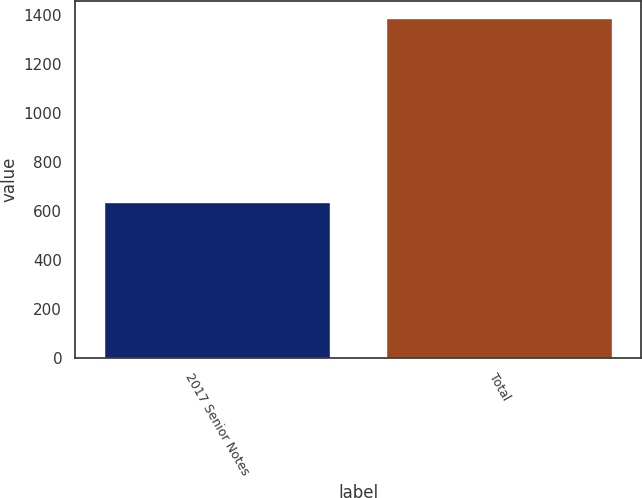<chart> <loc_0><loc_0><loc_500><loc_500><bar_chart><fcel>2017 Senior Notes<fcel>Total<nl><fcel>637<fcel>1388<nl></chart> 